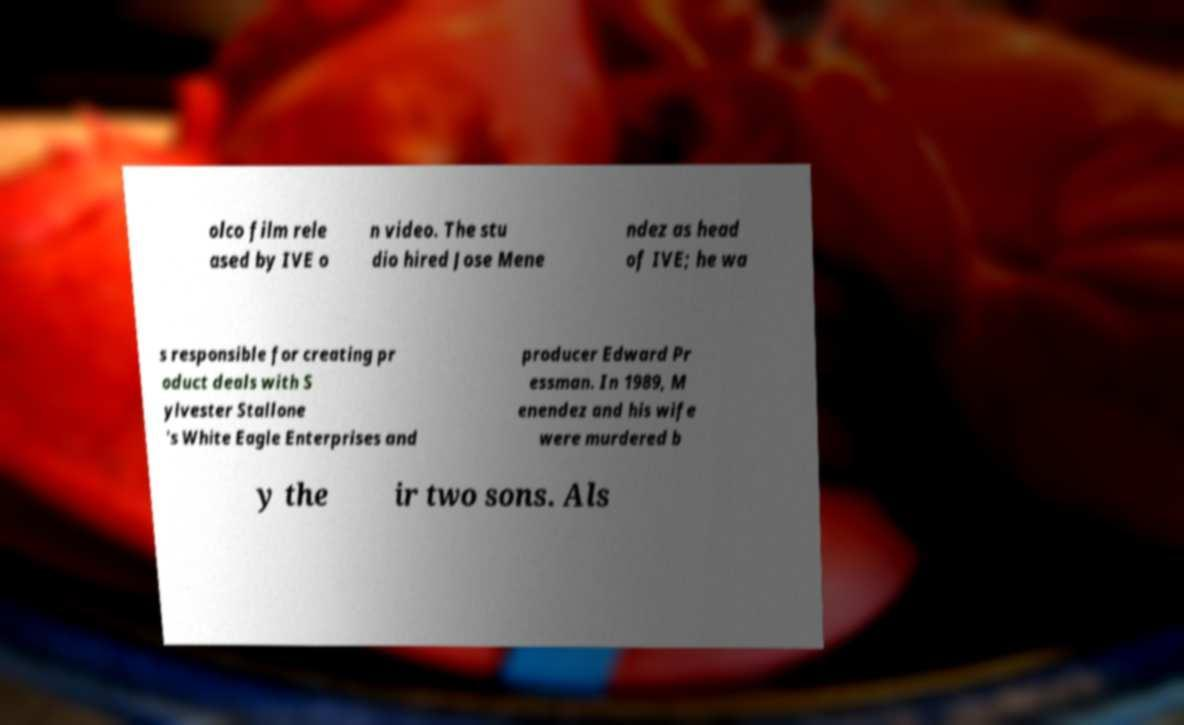Can you read and provide the text displayed in the image?This photo seems to have some interesting text. Can you extract and type it out for me? olco film rele ased by IVE o n video. The stu dio hired Jose Mene ndez as head of IVE; he wa s responsible for creating pr oduct deals with S ylvester Stallone 's White Eagle Enterprises and producer Edward Pr essman. In 1989, M enendez and his wife were murdered b y the ir two sons. Als 